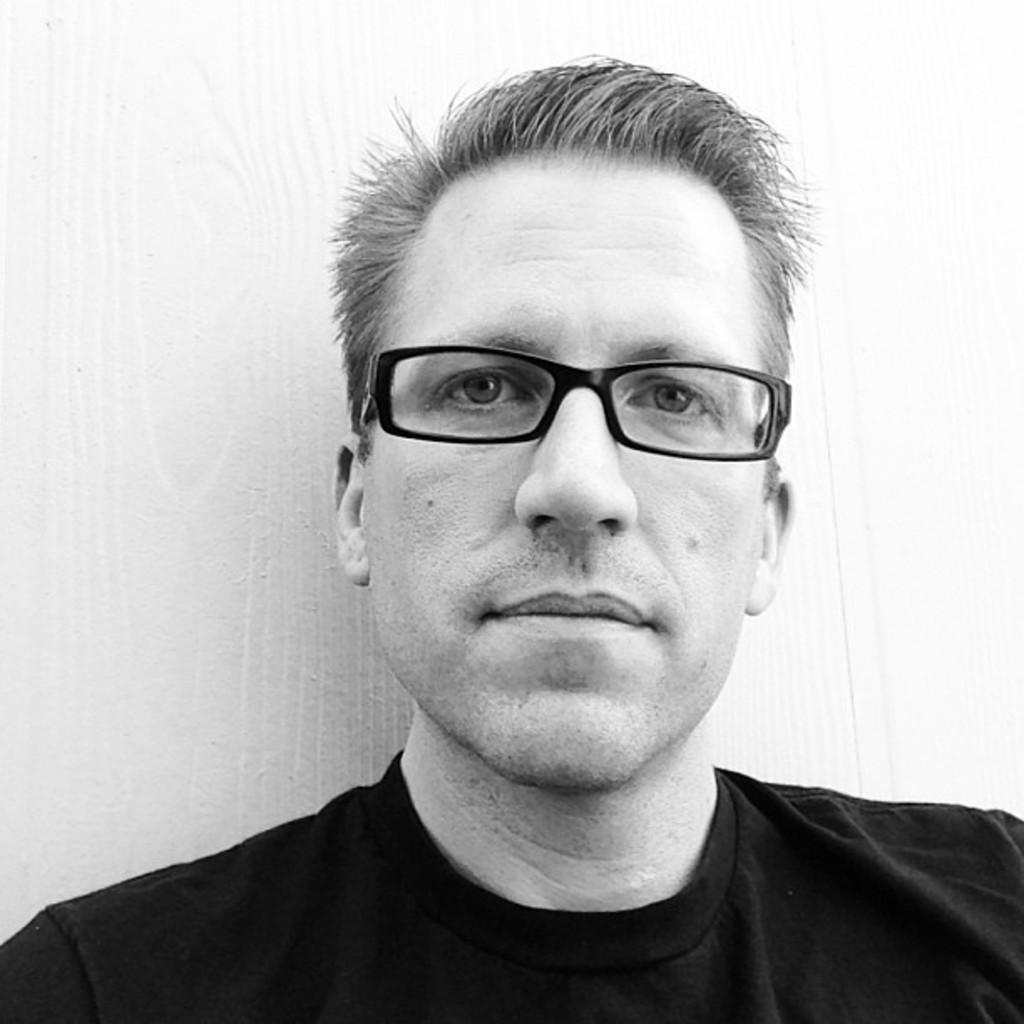Could you give a brief overview of what you see in this image? In this image I can see a man. I can see he is wearing specs, t shirt and I can see this image is black and white in colour. 